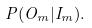<formula> <loc_0><loc_0><loc_500><loc_500>P ( O _ { m } | I _ { m } ) .</formula> 